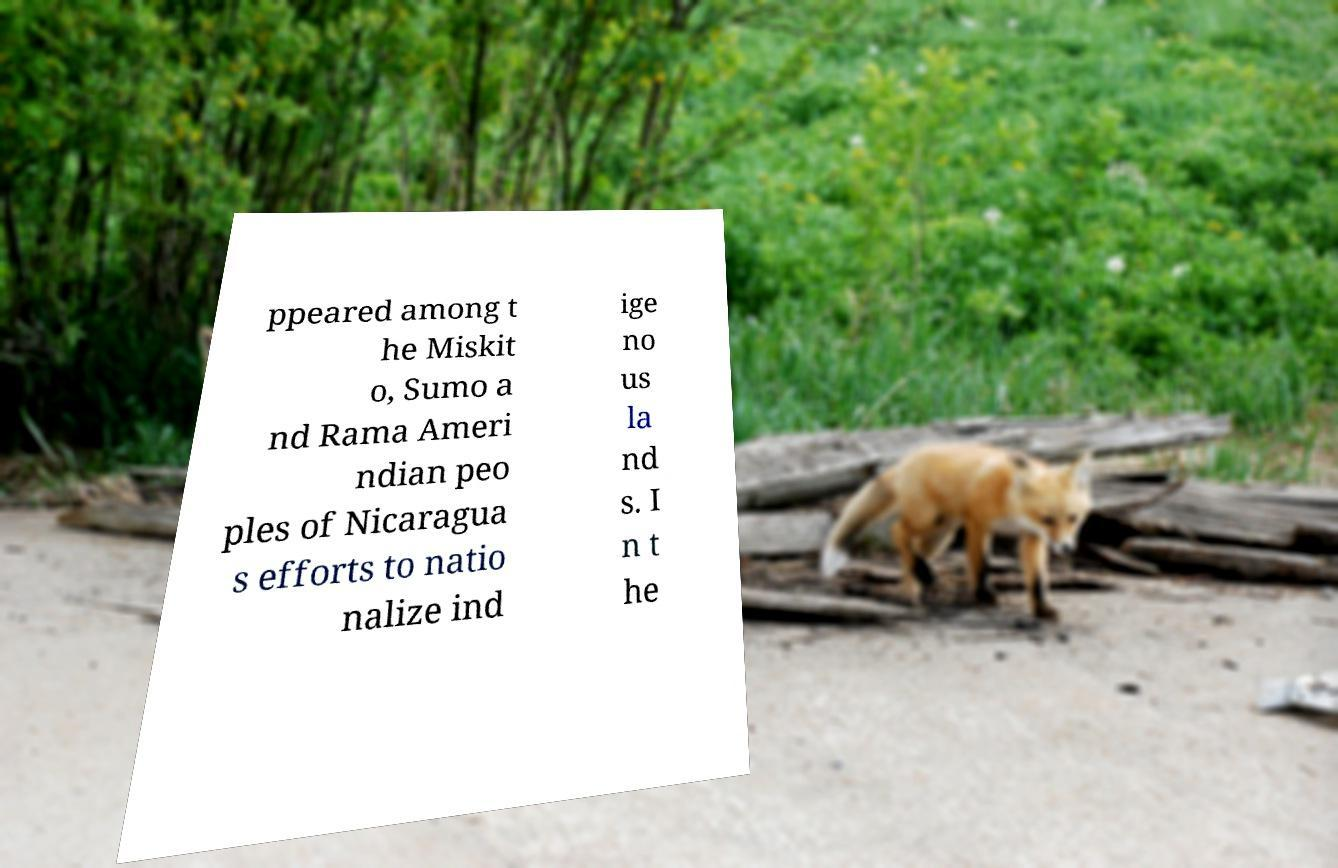I need the written content from this picture converted into text. Can you do that? ppeared among t he Miskit o, Sumo a nd Rama Ameri ndian peo ples of Nicaragua s efforts to natio nalize ind ige no us la nd s. I n t he 